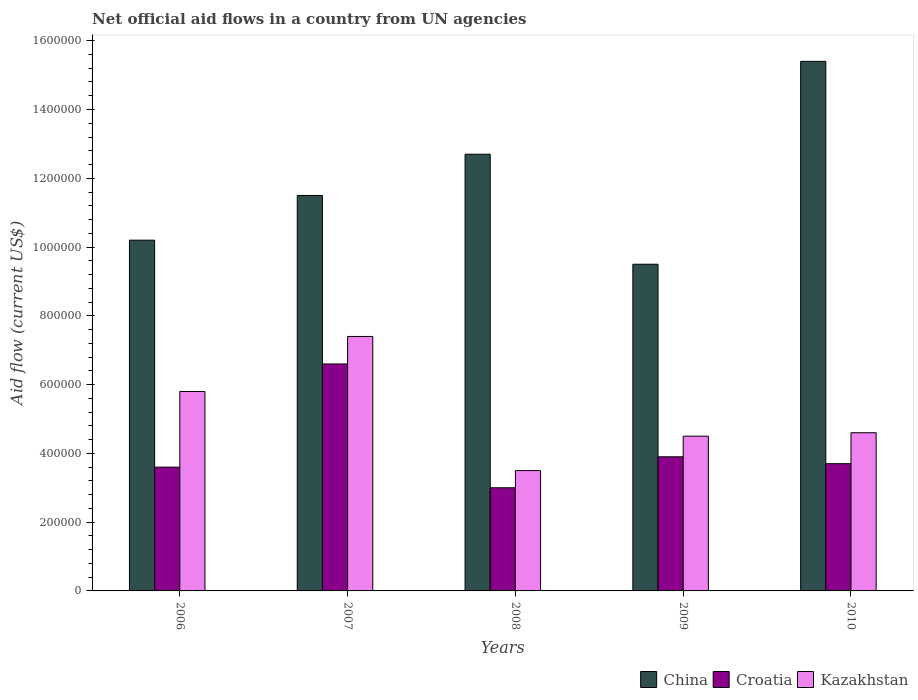How many different coloured bars are there?
Your response must be concise. 3. Are the number of bars per tick equal to the number of legend labels?
Give a very brief answer. Yes. Across all years, what is the maximum net official aid flow in Kazakhstan?
Your answer should be compact. 7.40e+05. Across all years, what is the minimum net official aid flow in Croatia?
Your answer should be compact. 3.00e+05. In which year was the net official aid flow in China maximum?
Keep it short and to the point. 2010. What is the total net official aid flow in China in the graph?
Make the answer very short. 5.93e+06. What is the difference between the net official aid flow in Kazakhstan in 2007 and that in 2010?
Offer a very short reply. 2.80e+05. What is the average net official aid flow in China per year?
Provide a succinct answer. 1.19e+06. In the year 2007, what is the difference between the net official aid flow in China and net official aid flow in Croatia?
Offer a very short reply. 4.90e+05. In how many years, is the net official aid flow in Croatia greater than 1120000 US$?
Your response must be concise. 0. What is the ratio of the net official aid flow in Kazakhstan in 2008 to that in 2009?
Give a very brief answer. 0.78. Is the difference between the net official aid flow in China in 2007 and 2010 greater than the difference between the net official aid flow in Croatia in 2007 and 2010?
Provide a short and direct response. No. What is the difference between the highest and the second highest net official aid flow in China?
Offer a very short reply. 2.70e+05. What is the difference between the highest and the lowest net official aid flow in Kazakhstan?
Give a very brief answer. 3.90e+05. Is the sum of the net official aid flow in China in 2009 and 2010 greater than the maximum net official aid flow in Croatia across all years?
Ensure brevity in your answer.  Yes. What does the 2nd bar from the left in 2009 represents?
Give a very brief answer. Croatia. Is it the case that in every year, the sum of the net official aid flow in Kazakhstan and net official aid flow in China is greater than the net official aid flow in Croatia?
Provide a succinct answer. Yes. Are the values on the major ticks of Y-axis written in scientific E-notation?
Make the answer very short. No. Does the graph contain any zero values?
Provide a succinct answer. No. Where does the legend appear in the graph?
Give a very brief answer. Bottom right. How are the legend labels stacked?
Provide a short and direct response. Horizontal. What is the title of the graph?
Keep it short and to the point. Net official aid flows in a country from UN agencies. Does "High income: OECD" appear as one of the legend labels in the graph?
Your response must be concise. No. What is the label or title of the X-axis?
Your answer should be very brief. Years. What is the Aid flow (current US$) of China in 2006?
Your response must be concise. 1.02e+06. What is the Aid flow (current US$) of Kazakhstan in 2006?
Keep it short and to the point. 5.80e+05. What is the Aid flow (current US$) of China in 2007?
Provide a short and direct response. 1.15e+06. What is the Aid flow (current US$) in Kazakhstan in 2007?
Your response must be concise. 7.40e+05. What is the Aid flow (current US$) in China in 2008?
Keep it short and to the point. 1.27e+06. What is the Aid flow (current US$) in Kazakhstan in 2008?
Your answer should be compact. 3.50e+05. What is the Aid flow (current US$) of China in 2009?
Offer a very short reply. 9.50e+05. What is the Aid flow (current US$) of Croatia in 2009?
Give a very brief answer. 3.90e+05. What is the Aid flow (current US$) of Kazakhstan in 2009?
Your answer should be compact. 4.50e+05. What is the Aid flow (current US$) in China in 2010?
Give a very brief answer. 1.54e+06. What is the Aid flow (current US$) of Croatia in 2010?
Provide a short and direct response. 3.70e+05. Across all years, what is the maximum Aid flow (current US$) in China?
Your answer should be compact. 1.54e+06. Across all years, what is the maximum Aid flow (current US$) in Kazakhstan?
Offer a terse response. 7.40e+05. Across all years, what is the minimum Aid flow (current US$) in China?
Make the answer very short. 9.50e+05. Across all years, what is the minimum Aid flow (current US$) of Croatia?
Ensure brevity in your answer.  3.00e+05. What is the total Aid flow (current US$) of China in the graph?
Offer a terse response. 5.93e+06. What is the total Aid flow (current US$) in Croatia in the graph?
Your answer should be compact. 2.08e+06. What is the total Aid flow (current US$) of Kazakhstan in the graph?
Provide a short and direct response. 2.58e+06. What is the difference between the Aid flow (current US$) of China in 2006 and that in 2007?
Give a very brief answer. -1.30e+05. What is the difference between the Aid flow (current US$) in Croatia in 2006 and that in 2007?
Ensure brevity in your answer.  -3.00e+05. What is the difference between the Aid flow (current US$) in China in 2006 and that in 2009?
Provide a short and direct response. 7.00e+04. What is the difference between the Aid flow (current US$) of Kazakhstan in 2006 and that in 2009?
Your response must be concise. 1.30e+05. What is the difference between the Aid flow (current US$) of China in 2006 and that in 2010?
Make the answer very short. -5.20e+05. What is the difference between the Aid flow (current US$) of Kazakhstan in 2006 and that in 2010?
Make the answer very short. 1.20e+05. What is the difference between the Aid flow (current US$) in China in 2007 and that in 2008?
Make the answer very short. -1.20e+05. What is the difference between the Aid flow (current US$) in China in 2007 and that in 2009?
Offer a very short reply. 2.00e+05. What is the difference between the Aid flow (current US$) in Croatia in 2007 and that in 2009?
Give a very brief answer. 2.70e+05. What is the difference between the Aid flow (current US$) in China in 2007 and that in 2010?
Provide a short and direct response. -3.90e+05. What is the difference between the Aid flow (current US$) of Croatia in 2007 and that in 2010?
Offer a terse response. 2.90e+05. What is the difference between the Aid flow (current US$) of Kazakhstan in 2008 and that in 2009?
Your response must be concise. -1.00e+05. What is the difference between the Aid flow (current US$) in China in 2008 and that in 2010?
Your response must be concise. -2.70e+05. What is the difference between the Aid flow (current US$) in Kazakhstan in 2008 and that in 2010?
Provide a succinct answer. -1.10e+05. What is the difference between the Aid flow (current US$) in China in 2009 and that in 2010?
Your response must be concise. -5.90e+05. What is the difference between the Aid flow (current US$) of Croatia in 2009 and that in 2010?
Your answer should be compact. 2.00e+04. What is the difference between the Aid flow (current US$) in China in 2006 and the Aid flow (current US$) in Croatia in 2007?
Provide a succinct answer. 3.60e+05. What is the difference between the Aid flow (current US$) of Croatia in 2006 and the Aid flow (current US$) of Kazakhstan in 2007?
Offer a terse response. -3.80e+05. What is the difference between the Aid flow (current US$) of China in 2006 and the Aid flow (current US$) of Croatia in 2008?
Your answer should be compact. 7.20e+05. What is the difference between the Aid flow (current US$) of China in 2006 and the Aid flow (current US$) of Kazakhstan in 2008?
Keep it short and to the point. 6.70e+05. What is the difference between the Aid flow (current US$) in China in 2006 and the Aid flow (current US$) in Croatia in 2009?
Ensure brevity in your answer.  6.30e+05. What is the difference between the Aid flow (current US$) of China in 2006 and the Aid flow (current US$) of Kazakhstan in 2009?
Provide a succinct answer. 5.70e+05. What is the difference between the Aid flow (current US$) in Croatia in 2006 and the Aid flow (current US$) in Kazakhstan in 2009?
Keep it short and to the point. -9.00e+04. What is the difference between the Aid flow (current US$) of China in 2006 and the Aid flow (current US$) of Croatia in 2010?
Offer a very short reply. 6.50e+05. What is the difference between the Aid flow (current US$) of China in 2006 and the Aid flow (current US$) of Kazakhstan in 2010?
Give a very brief answer. 5.60e+05. What is the difference between the Aid flow (current US$) in Croatia in 2006 and the Aid flow (current US$) in Kazakhstan in 2010?
Offer a very short reply. -1.00e+05. What is the difference between the Aid flow (current US$) of China in 2007 and the Aid flow (current US$) of Croatia in 2008?
Offer a terse response. 8.50e+05. What is the difference between the Aid flow (current US$) in Croatia in 2007 and the Aid flow (current US$) in Kazakhstan in 2008?
Keep it short and to the point. 3.10e+05. What is the difference between the Aid flow (current US$) of China in 2007 and the Aid flow (current US$) of Croatia in 2009?
Provide a succinct answer. 7.60e+05. What is the difference between the Aid flow (current US$) in Croatia in 2007 and the Aid flow (current US$) in Kazakhstan in 2009?
Provide a short and direct response. 2.10e+05. What is the difference between the Aid flow (current US$) of China in 2007 and the Aid flow (current US$) of Croatia in 2010?
Offer a terse response. 7.80e+05. What is the difference between the Aid flow (current US$) of China in 2007 and the Aid flow (current US$) of Kazakhstan in 2010?
Keep it short and to the point. 6.90e+05. What is the difference between the Aid flow (current US$) of Croatia in 2007 and the Aid flow (current US$) of Kazakhstan in 2010?
Ensure brevity in your answer.  2.00e+05. What is the difference between the Aid flow (current US$) in China in 2008 and the Aid flow (current US$) in Croatia in 2009?
Your answer should be compact. 8.80e+05. What is the difference between the Aid flow (current US$) in China in 2008 and the Aid flow (current US$) in Kazakhstan in 2009?
Your answer should be compact. 8.20e+05. What is the difference between the Aid flow (current US$) of China in 2008 and the Aid flow (current US$) of Kazakhstan in 2010?
Keep it short and to the point. 8.10e+05. What is the difference between the Aid flow (current US$) in Croatia in 2008 and the Aid flow (current US$) in Kazakhstan in 2010?
Provide a short and direct response. -1.60e+05. What is the difference between the Aid flow (current US$) in China in 2009 and the Aid flow (current US$) in Croatia in 2010?
Make the answer very short. 5.80e+05. What is the average Aid flow (current US$) in China per year?
Give a very brief answer. 1.19e+06. What is the average Aid flow (current US$) in Croatia per year?
Your answer should be very brief. 4.16e+05. What is the average Aid flow (current US$) in Kazakhstan per year?
Offer a very short reply. 5.16e+05. In the year 2007, what is the difference between the Aid flow (current US$) in China and Aid flow (current US$) in Croatia?
Provide a short and direct response. 4.90e+05. In the year 2007, what is the difference between the Aid flow (current US$) of China and Aid flow (current US$) of Kazakhstan?
Offer a terse response. 4.10e+05. In the year 2007, what is the difference between the Aid flow (current US$) of Croatia and Aid flow (current US$) of Kazakhstan?
Your answer should be compact. -8.00e+04. In the year 2008, what is the difference between the Aid flow (current US$) of China and Aid flow (current US$) of Croatia?
Keep it short and to the point. 9.70e+05. In the year 2008, what is the difference between the Aid flow (current US$) of China and Aid flow (current US$) of Kazakhstan?
Keep it short and to the point. 9.20e+05. In the year 2008, what is the difference between the Aid flow (current US$) in Croatia and Aid flow (current US$) in Kazakhstan?
Offer a very short reply. -5.00e+04. In the year 2009, what is the difference between the Aid flow (current US$) in China and Aid flow (current US$) in Croatia?
Offer a terse response. 5.60e+05. In the year 2009, what is the difference between the Aid flow (current US$) in Croatia and Aid flow (current US$) in Kazakhstan?
Make the answer very short. -6.00e+04. In the year 2010, what is the difference between the Aid flow (current US$) of China and Aid flow (current US$) of Croatia?
Your answer should be very brief. 1.17e+06. In the year 2010, what is the difference between the Aid flow (current US$) in China and Aid flow (current US$) in Kazakhstan?
Your answer should be compact. 1.08e+06. What is the ratio of the Aid flow (current US$) of China in 2006 to that in 2007?
Offer a very short reply. 0.89. What is the ratio of the Aid flow (current US$) of Croatia in 2006 to that in 2007?
Offer a terse response. 0.55. What is the ratio of the Aid flow (current US$) in Kazakhstan in 2006 to that in 2007?
Provide a succinct answer. 0.78. What is the ratio of the Aid flow (current US$) in China in 2006 to that in 2008?
Your answer should be very brief. 0.8. What is the ratio of the Aid flow (current US$) of Croatia in 2006 to that in 2008?
Your response must be concise. 1.2. What is the ratio of the Aid flow (current US$) of Kazakhstan in 2006 to that in 2008?
Give a very brief answer. 1.66. What is the ratio of the Aid flow (current US$) of China in 2006 to that in 2009?
Ensure brevity in your answer.  1.07. What is the ratio of the Aid flow (current US$) in Kazakhstan in 2006 to that in 2009?
Provide a short and direct response. 1.29. What is the ratio of the Aid flow (current US$) of China in 2006 to that in 2010?
Provide a succinct answer. 0.66. What is the ratio of the Aid flow (current US$) of Croatia in 2006 to that in 2010?
Make the answer very short. 0.97. What is the ratio of the Aid flow (current US$) in Kazakhstan in 2006 to that in 2010?
Ensure brevity in your answer.  1.26. What is the ratio of the Aid flow (current US$) of China in 2007 to that in 2008?
Keep it short and to the point. 0.91. What is the ratio of the Aid flow (current US$) in Croatia in 2007 to that in 2008?
Offer a very short reply. 2.2. What is the ratio of the Aid flow (current US$) in Kazakhstan in 2007 to that in 2008?
Ensure brevity in your answer.  2.11. What is the ratio of the Aid flow (current US$) in China in 2007 to that in 2009?
Provide a succinct answer. 1.21. What is the ratio of the Aid flow (current US$) in Croatia in 2007 to that in 2009?
Your answer should be very brief. 1.69. What is the ratio of the Aid flow (current US$) in Kazakhstan in 2007 to that in 2009?
Give a very brief answer. 1.64. What is the ratio of the Aid flow (current US$) in China in 2007 to that in 2010?
Keep it short and to the point. 0.75. What is the ratio of the Aid flow (current US$) in Croatia in 2007 to that in 2010?
Your answer should be compact. 1.78. What is the ratio of the Aid flow (current US$) of Kazakhstan in 2007 to that in 2010?
Give a very brief answer. 1.61. What is the ratio of the Aid flow (current US$) of China in 2008 to that in 2009?
Your answer should be compact. 1.34. What is the ratio of the Aid flow (current US$) in Croatia in 2008 to that in 2009?
Provide a short and direct response. 0.77. What is the ratio of the Aid flow (current US$) in China in 2008 to that in 2010?
Ensure brevity in your answer.  0.82. What is the ratio of the Aid flow (current US$) of Croatia in 2008 to that in 2010?
Provide a short and direct response. 0.81. What is the ratio of the Aid flow (current US$) of Kazakhstan in 2008 to that in 2010?
Offer a very short reply. 0.76. What is the ratio of the Aid flow (current US$) in China in 2009 to that in 2010?
Keep it short and to the point. 0.62. What is the ratio of the Aid flow (current US$) in Croatia in 2009 to that in 2010?
Offer a very short reply. 1.05. What is the ratio of the Aid flow (current US$) of Kazakhstan in 2009 to that in 2010?
Your answer should be very brief. 0.98. What is the difference between the highest and the second highest Aid flow (current US$) in China?
Give a very brief answer. 2.70e+05. What is the difference between the highest and the second highest Aid flow (current US$) of Croatia?
Your answer should be very brief. 2.70e+05. What is the difference between the highest and the second highest Aid flow (current US$) of Kazakhstan?
Ensure brevity in your answer.  1.60e+05. What is the difference between the highest and the lowest Aid flow (current US$) of China?
Offer a very short reply. 5.90e+05. What is the difference between the highest and the lowest Aid flow (current US$) in Croatia?
Offer a very short reply. 3.60e+05. 